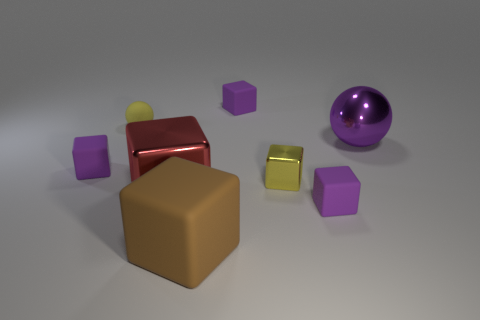Subtract all purple cylinders. How many purple blocks are left? 3 Subtract all big metal blocks. How many blocks are left? 5 Subtract all red cubes. How many cubes are left? 5 Subtract all gray cubes. Subtract all yellow cylinders. How many cubes are left? 6 Add 1 green blocks. How many objects exist? 9 Subtract all cubes. How many objects are left? 2 Add 5 big purple metallic objects. How many big purple metallic objects are left? 6 Add 5 yellow matte spheres. How many yellow matte spheres exist? 6 Subtract 1 yellow blocks. How many objects are left? 7 Subtract all small purple cubes. Subtract all large red shiny blocks. How many objects are left? 4 